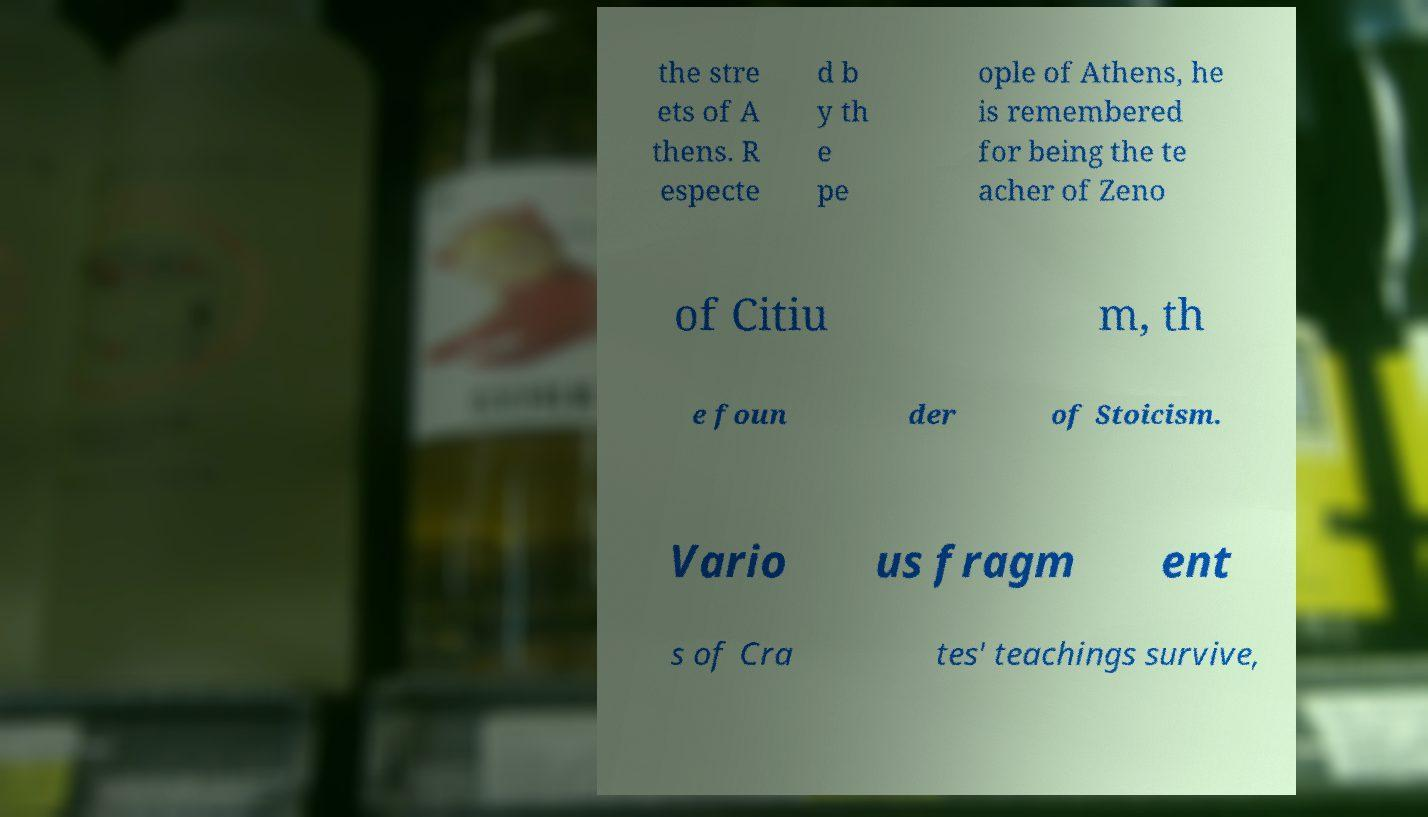What messages or text are displayed in this image? I need them in a readable, typed format. the stre ets of A thens. R especte d b y th e pe ople of Athens, he is remembered for being the te acher of Zeno of Citiu m, th e foun der of Stoicism. Vario us fragm ent s of Cra tes' teachings survive, 